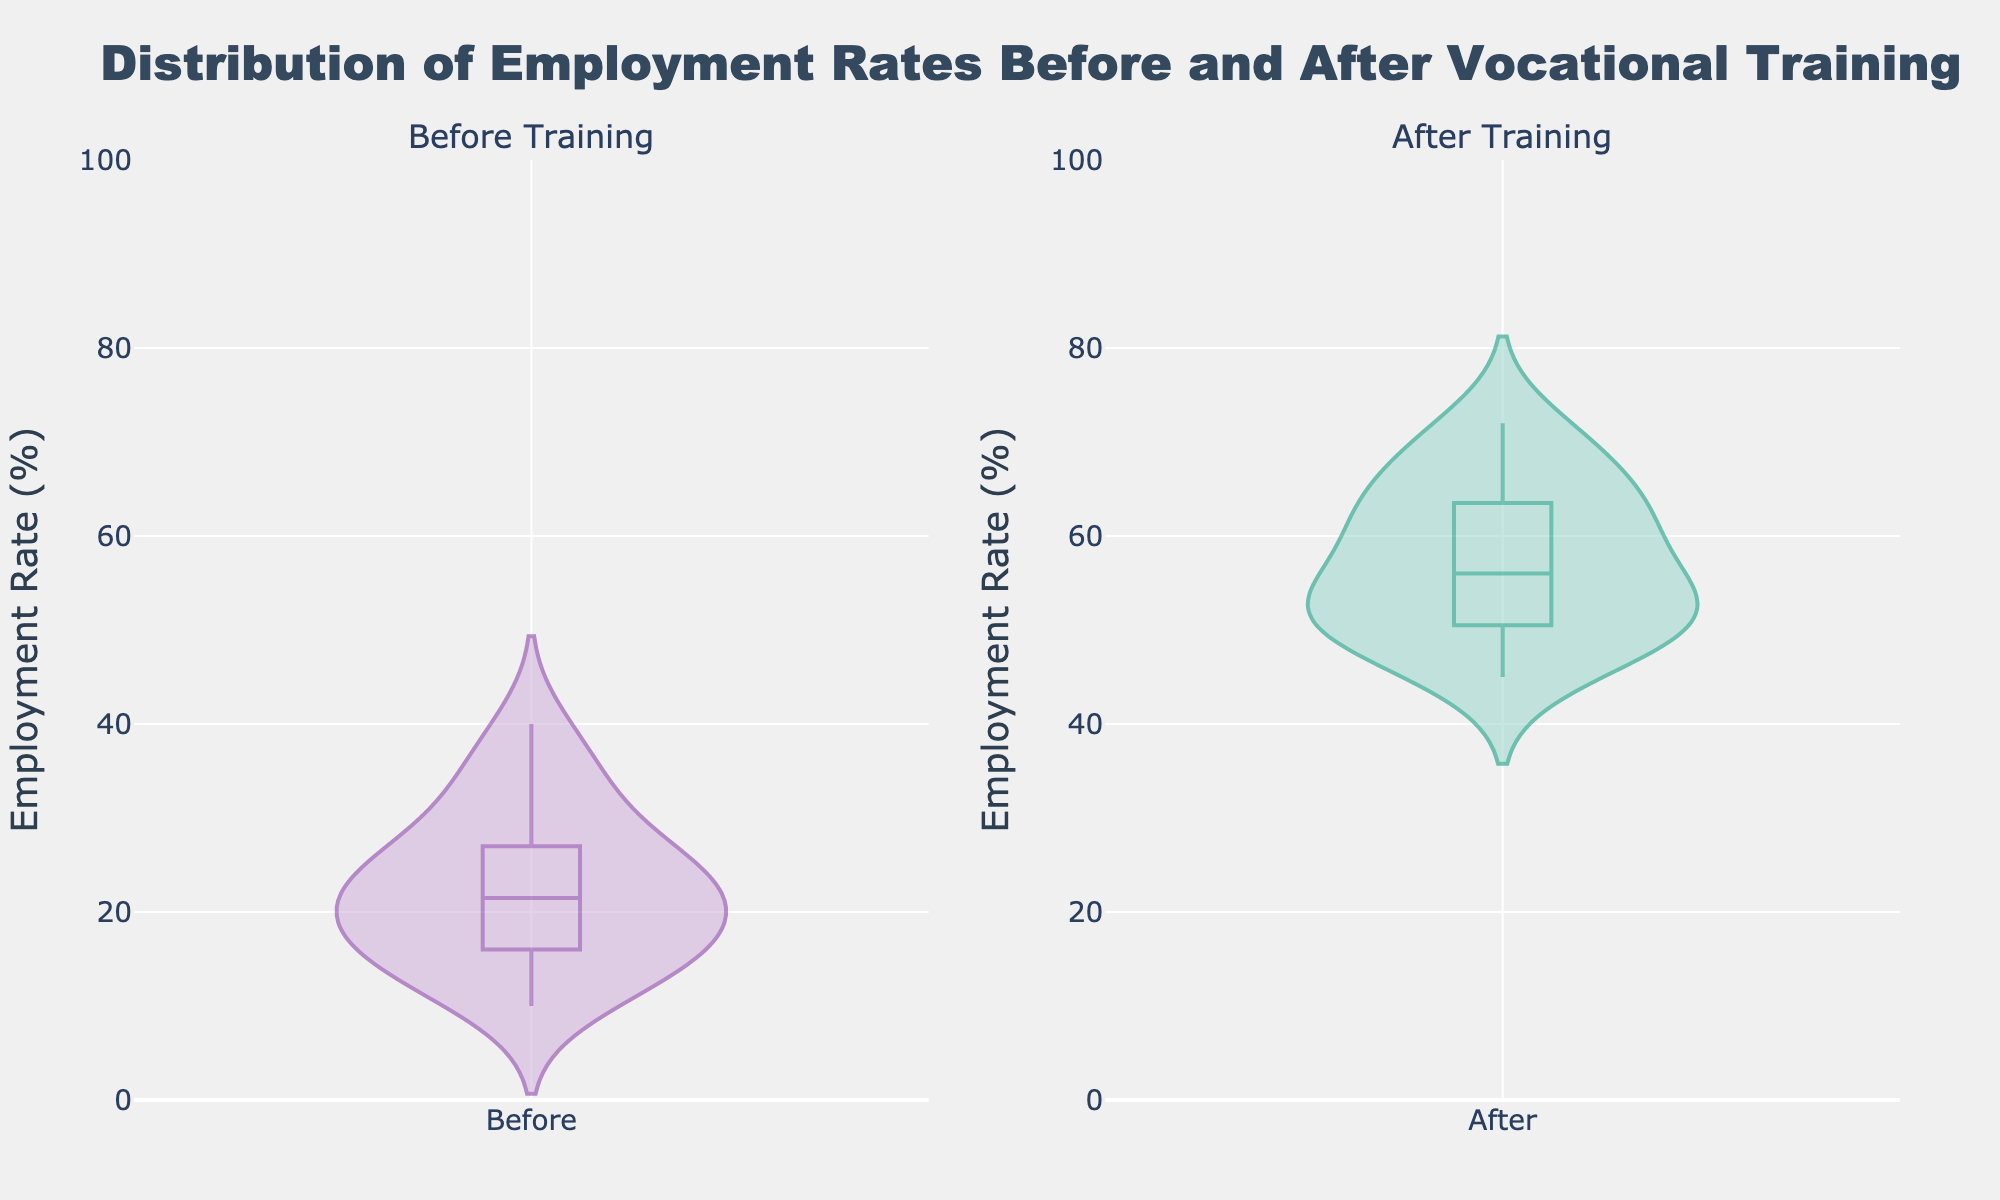What is the title of the figure? The title is prominently displayed at the top of the figure and reads "Distribution of Employment Rates Before and After Vocational Training."
Answer: Distribution of Employment Rates Before and After Vocational Training What does the y-axis represent in the figure? The y-axis is labeled "Employment Rate (%)" and measures the employment rates of participants.
Answer: Employment Rate (%) What are the colors of the violin plots for before and after training? The violin plot for before training uses shades of purple, and the plot for after training uses shades of green.
Answer: Purple and Green What is the general shape of the employment rate distribution before training? The distribution before training appears to have a wider spread and a lower median compared to the distribution after training.
Answer: Wider spread, lower median How does the distribution of employment rates change after the training compared to before? The distribution after training is less spread out and has a higher median, indicating an overall increase in employment rates.
Answer: Less spread, higher median What is the range of employment rates displayed on the y-axis? The y-axis ranges from 0 to 100, covering all possible employment rates.
Answer: 0 to 100 Which subplot shows a higher median employment rate? By observing the central line inside each violin plot, the median employment rate in the after training subplot is higher than the before training subplot.
Answer: After training Are there any outliers in the distribution of employment rates before or after the training? The violin plots do not visibly show specific points as outliers, suggesting a smooth distribution without extreme values deviating far from the main distribution.
Answer: No visible outliers Is the box visible within the violin plots? Yes, there is a box visible within each violin plot indicating the interquartile range (IQR) of the data.
Answer: Yes 